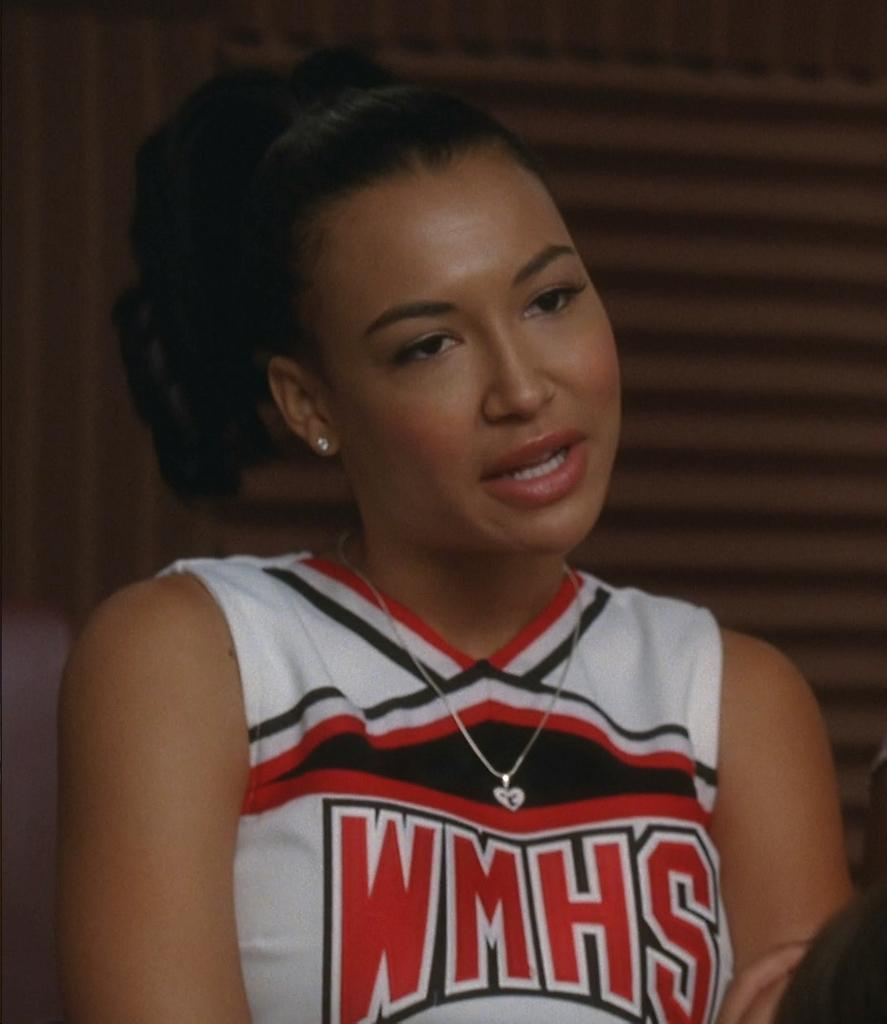<image>
Render a clear and concise summary of the photo. A cheerleader from WMHS is wearing a red, white, and black uniform. 